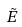Convert formula to latex. <formula><loc_0><loc_0><loc_500><loc_500>\tilde { E }</formula> 